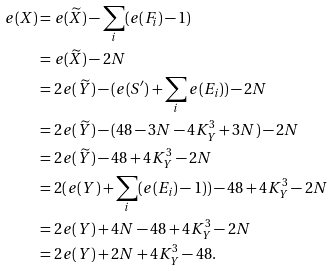<formula> <loc_0><loc_0><loc_500><loc_500>e ( X ) & = e ( \widetilde { X } ) - \sum _ { i } ( e ( F _ { i } ) - 1 ) \\ & = e ( \widetilde { X } ) - 2 N \\ & = 2 e ( \widetilde { Y } ) - ( e ( S ^ { \prime } ) + \sum _ { i } e ( E _ { i } ) ) - 2 N \\ & = 2 e ( \widetilde { Y } ) - ( 4 8 - 3 N - 4 K _ { Y } ^ { 3 } + 3 N ) - 2 N \\ & = 2 e ( \widetilde { Y } ) - 4 8 + 4 K _ { Y } ^ { 3 } - 2 N \\ & = 2 ( e ( Y ) + \sum _ { i } ( e ( E _ { i } ) - 1 ) ) - 4 8 + 4 K _ { Y } ^ { 3 } - 2 N \\ & = 2 e ( Y ) + 4 N - 4 8 + 4 K _ { Y } ^ { 3 } - 2 N \\ & = 2 e ( Y ) + 2 N + 4 K _ { Y } ^ { 3 } - 4 8 .</formula> 